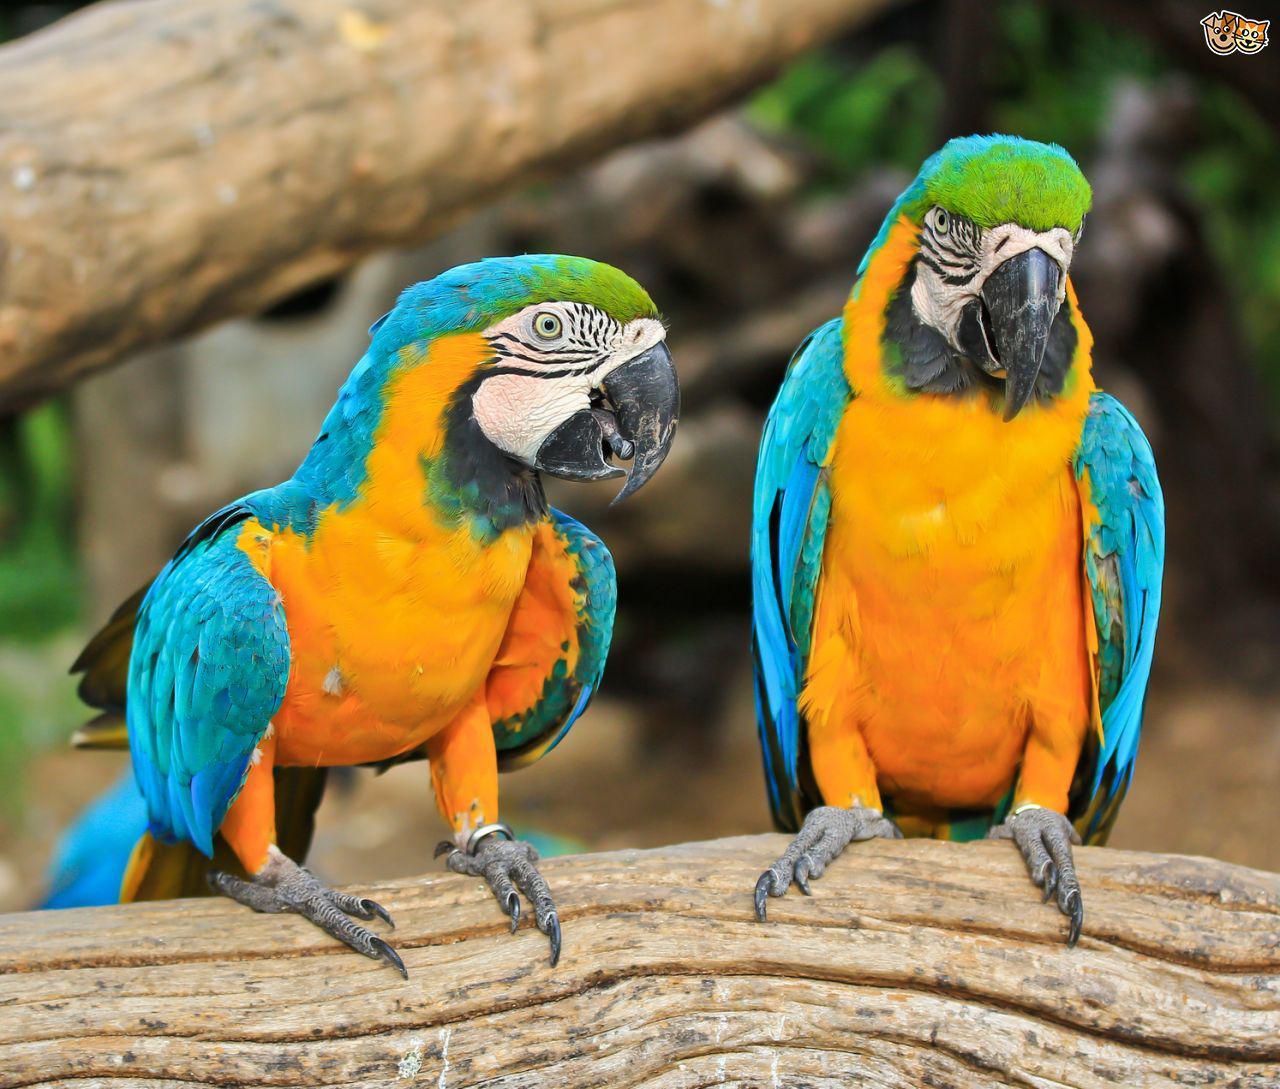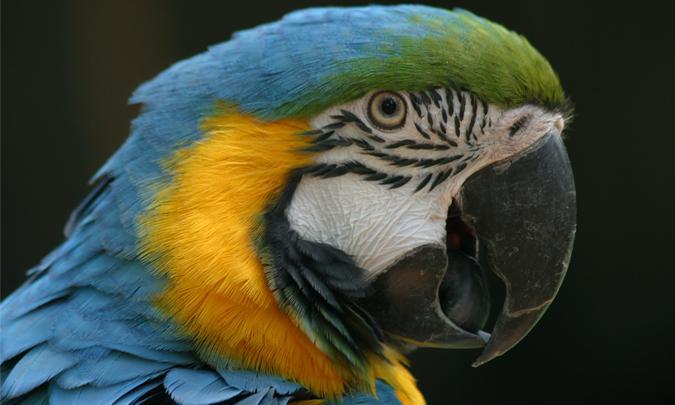The first image is the image on the left, the second image is the image on the right. For the images shown, is this caption "There are two birds, each perched on a branch." true? Answer yes or no. No. The first image is the image on the left, the second image is the image on the right. Assess this claim about the two images: "There are two blue and yellow birds". Correct or not? Answer yes or no. No. 